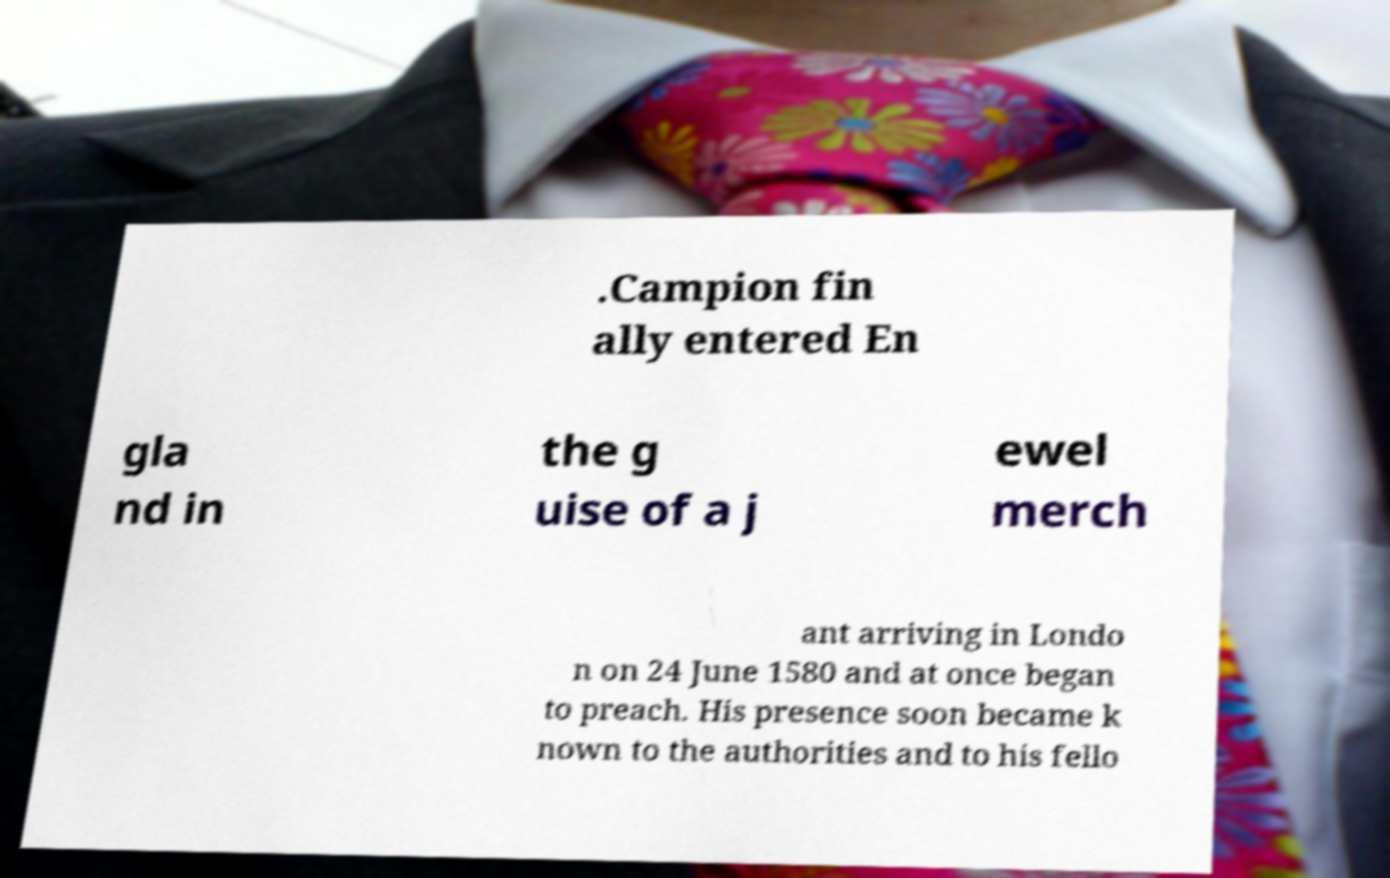I need the written content from this picture converted into text. Can you do that? .Campion fin ally entered En gla nd in the g uise of a j ewel merch ant arriving in Londo n on 24 June 1580 and at once began to preach. His presence soon became k nown to the authorities and to his fello 